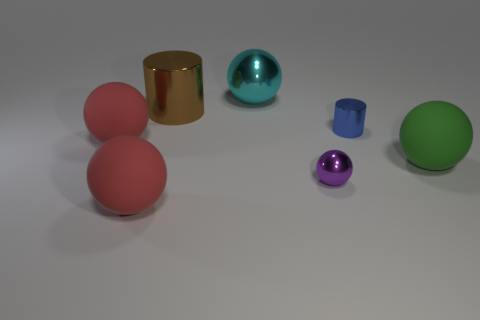There is a red object behind the green sphere; is its size the same as the purple metallic object?
Give a very brief answer. No. What color is the big matte thing that is right of the tiny blue thing?
Offer a very short reply. Green. How many large blue shiny spheres are there?
Give a very brief answer. 0. What shape is the tiny blue object that is the same material as the big brown thing?
Offer a terse response. Cylinder. Is the color of the big matte sphere that is to the right of the big cylinder the same as the metal object in front of the small shiny cylinder?
Your response must be concise. No. Are there an equal number of cyan balls that are to the left of the blue metal cylinder and large metal things?
Provide a short and direct response. No. There is a green thing; what number of small blue objects are left of it?
Your answer should be compact. 1. The brown cylinder is what size?
Offer a terse response. Large. The other sphere that is the same material as the large cyan sphere is what color?
Keep it short and to the point. Purple. What number of metal objects have the same size as the green matte thing?
Provide a short and direct response. 2. 